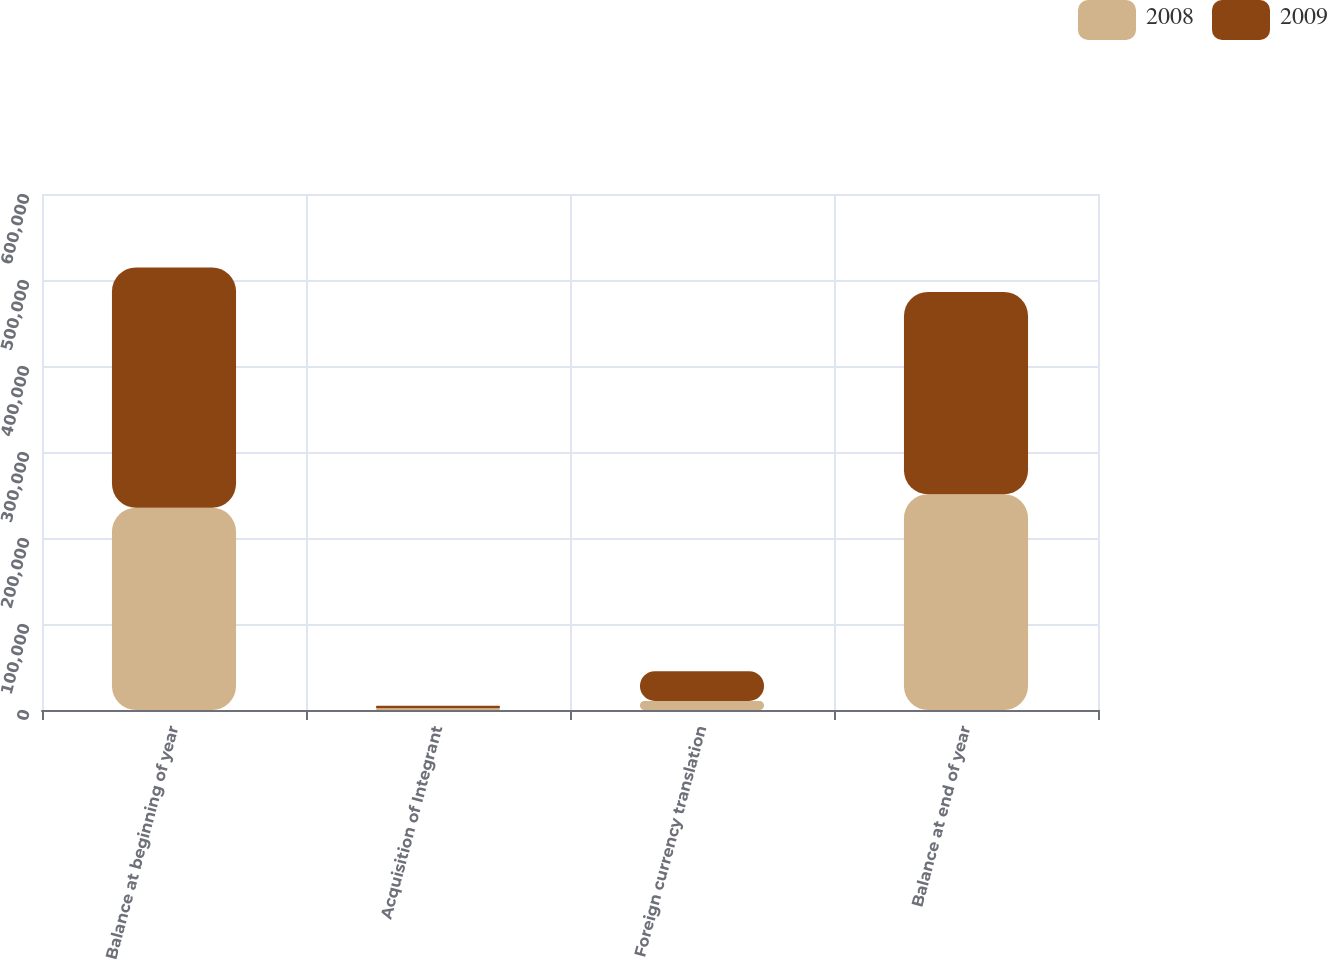Convert chart to OTSL. <chart><loc_0><loc_0><loc_500><loc_500><stacked_bar_chart><ecel><fcel>Balance at beginning of year<fcel>Acquisition of Integrant<fcel>Foreign currency translation<fcel>Balance at end of year<nl><fcel>2008<fcel>235175<fcel>2098<fcel>10537<fcel>250881<nl><fcel>2009<fcel>279469<fcel>2988<fcel>34633<fcel>235175<nl></chart> 